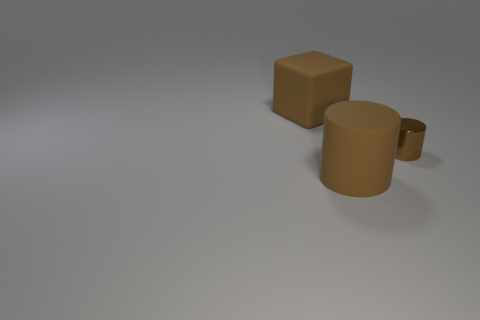Are there any other things that are the same size as the metal object?
Your response must be concise. No. Are there any small metallic cylinders?
Ensure brevity in your answer.  Yes. What number of other things are the same size as the brown cube?
Your answer should be very brief. 1. Is the material of the large block the same as the brown cylinder behind the rubber cylinder?
Ensure brevity in your answer.  No. Are there an equal number of tiny metal things to the left of the large brown cylinder and big rubber cylinders behind the large block?
Provide a short and direct response. Yes. What is the big block made of?
Offer a very short reply. Rubber. The rubber thing that is the same size as the brown cube is what color?
Provide a succinct answer. Brown. Are there any big brown objects to the right of the cylinder behind the brown matte cylinder?
Your answer should be compact. No. How many cubes are large brown things or small brown metal objects?
Offer a very short reply. 1. What size is the thing in front of the object to the right of the large brown thing that is in front of the small brown object?
Provide a short and direct response. Large. 